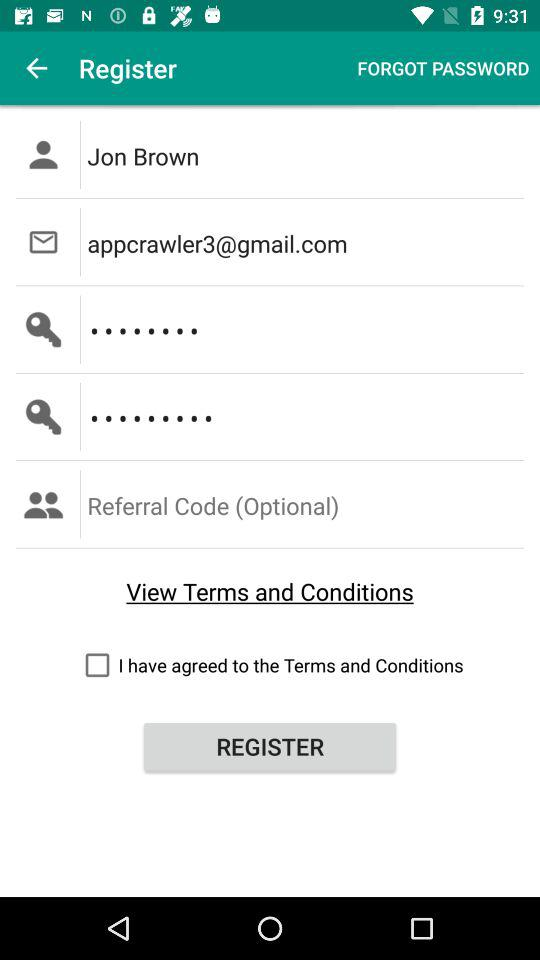What is the name of the user? The name of the user is Jon Brown. 